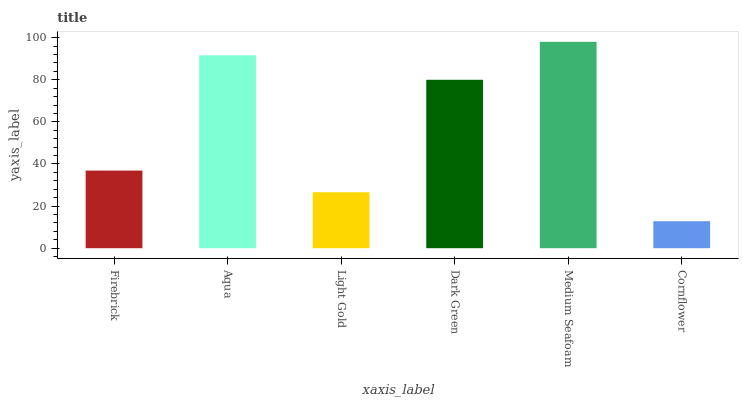Is Cornflower the minimum?
Answer yes or no. Yes. Is Medium Seafoam the maximum?
Answer yes or no. Yes. Is Aqua the minimum?
Answer yes or no. No. Is Aqua the maximum?
Answer yes or no. No. Is Aqua greater than Firebrick?
Answer yes or no. Yes. Is Firebrick less than Aqua?
Answer yes or no. Yes. Is Firebrick greater than Aqua?
Answer yes or no. No. Is Aqua less than Firebrick?
Answer yes or no. No. Is Dark Green the high median?
Answer yes or no. Yes. Is Firebrick the low median?
Answer yes or no. Yes. Is Aqua the high median?
Answer yes or no. No. Is Aqua the low median?
Answer yes or no. No. 